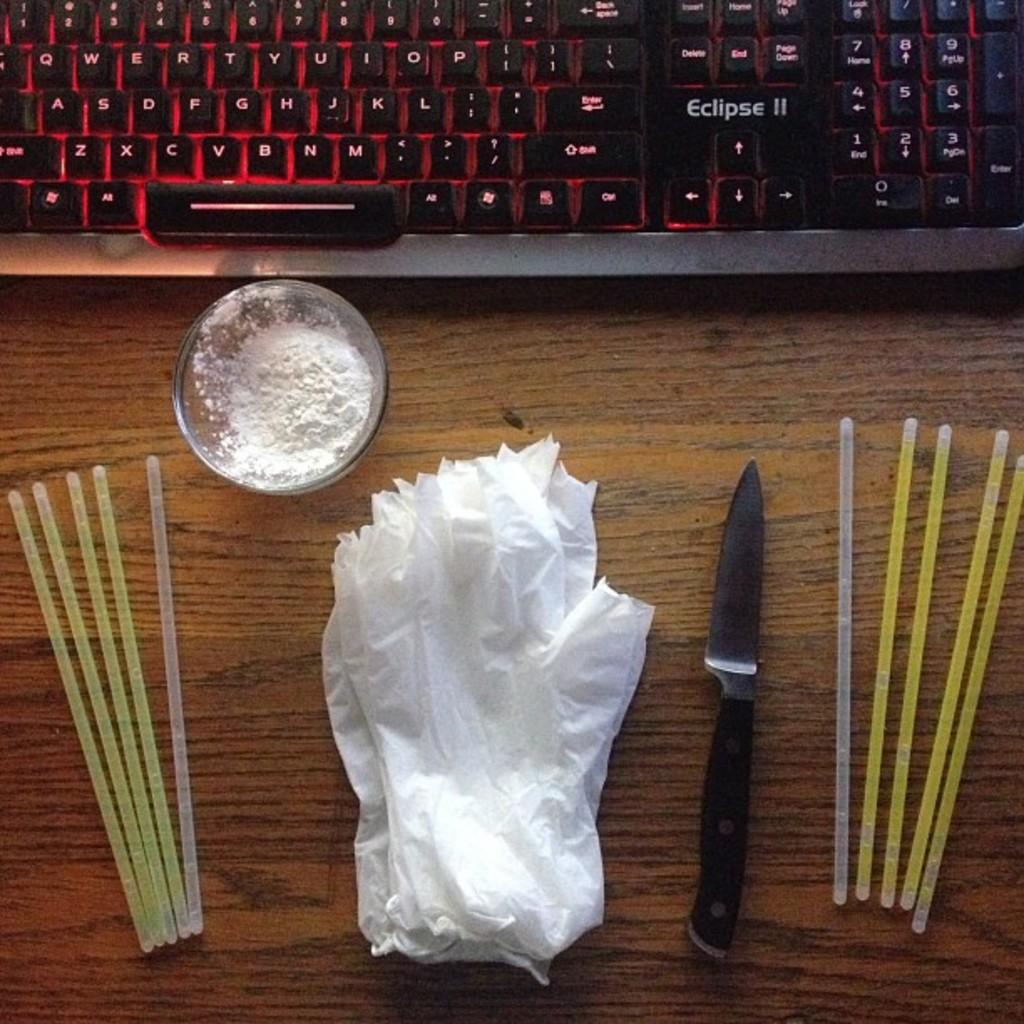What type of table is in the image? There is a wooden table in the image. What is placed on the wooden table? A keyboard, a glass bowl, a knife, and tissues are present on the table. Can you describe the bowl on the table? The bowl is made of glass. What might be used for cutting on the table? A knife is visible on the table. What type of brass instrument is being played on the table? There is no brass instrument present in the image; the only musical instrument mentioned is a keyboard. 